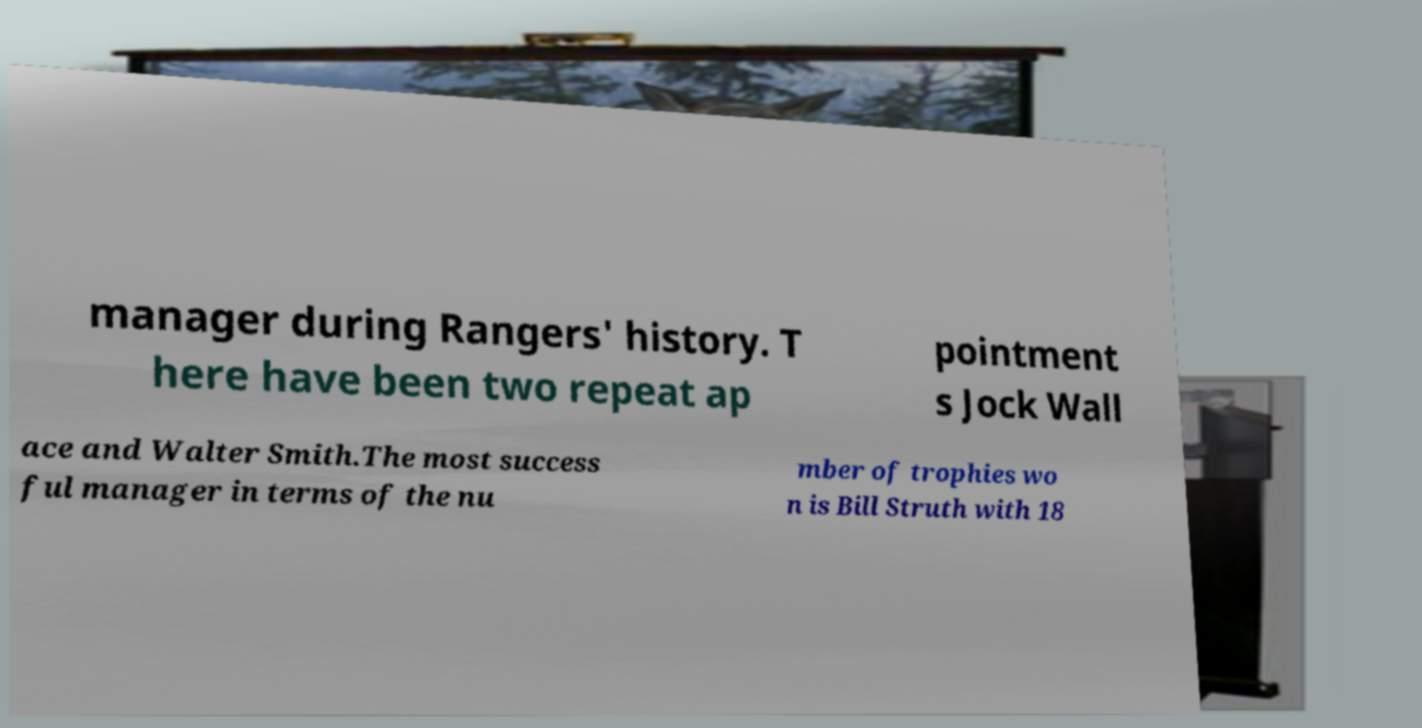There's text embedded in this image that I need extracted. Can you transcribe it verbatim? manager during Rangers' history. T here have been two repeat ap pointment s Jock Wall ace and Walter Smith.The most success ful manager in terms of the nu mber of trophies wo n is Bill Struth with 18 